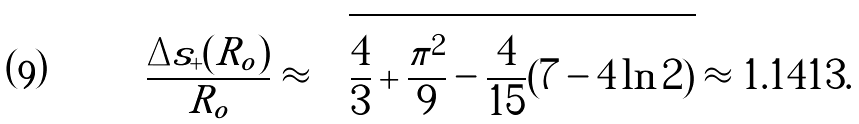Convert formula to latex. <formula><loc_0><loc_0><loc_500><loc_500>\frac { \Delta s _ { + } ( R _ { o } ) } { R _ { o } } \approx \sqrt { \frac { 4 } { 3 } + \frac { \pi ^ { 2 } } { 9 } - \frac { 4 } { 1 5 } ( 7 - 4 \ln 2 ) } \approx 1 . 1 4 1 3 .</formula> 